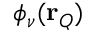<formula> <loc_0><loc_0><loc_500><loc_500>\phi _ { \nu } ( r _ { Q } )</formula> 